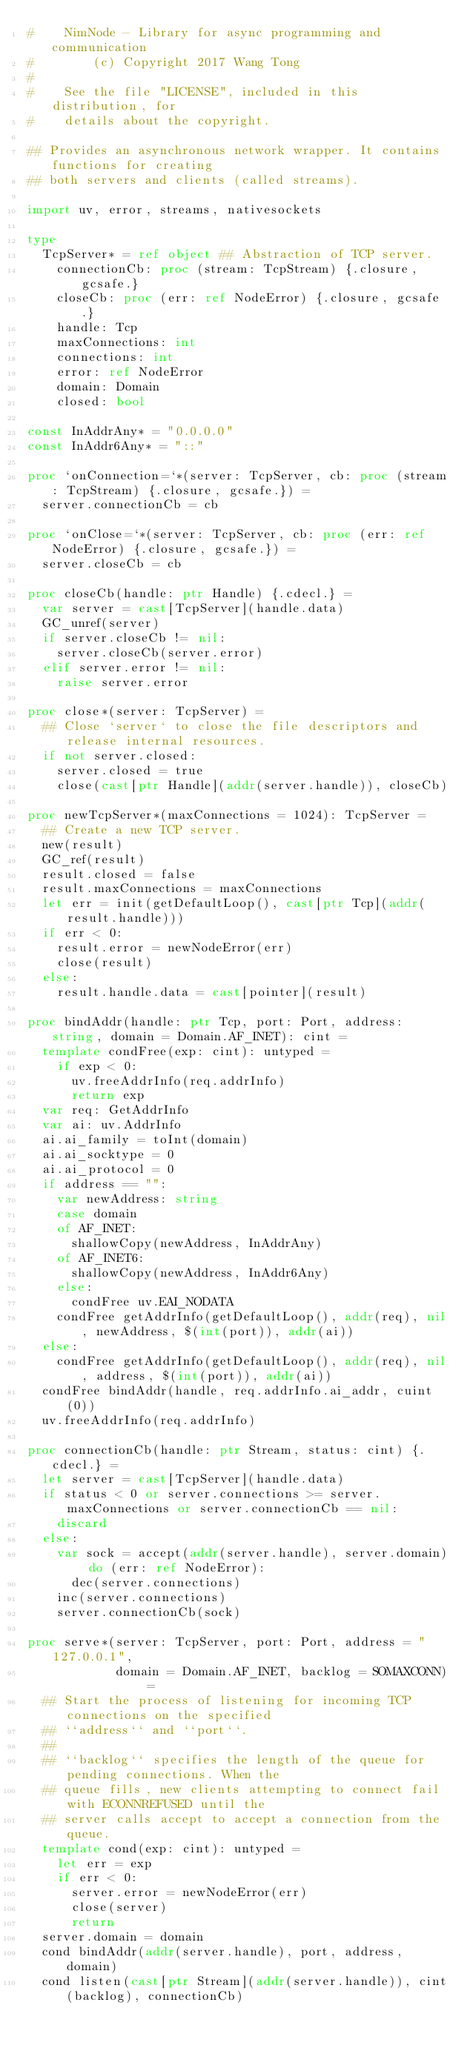Convert code to text. <code><loc_0><loc_0><loc_500><loc_500><_Nim_>#    NimNode - Library for async programming and communication
#        (c) Copyright 2017 Wang Tong
#
#    See the file "LICENSE", included in this distribution, for
#    details about the copyright.

## Provides an asynchronous network wrapper. It contains functions for creating 
## both servers and clients (called streams). 

import uv, error, streams, nativesockets

type
  TcpServer* = ref object ## Abstraction of TCP server.
    connectionCb: proc (stream: TcpStream) {.closure, gcsafe.}
    closeCb: proc (err: ref NodeError) {.closure, gcsafe.}
    handle: Tcp
    maxConnections: int
    connections: int
    error: ref NodeError
    domain: Domain
    closed: bool

const InAddrAny* = "0.0.0.0"
const InAddr6Any* = "::"

proc `onConnection=`*(server: TcpServer, cb: proc (stream: TcpStream) {.closure, gcsafe.}) =
  server.connectionCb = cb

proc `onClose=`*(server: TcpServer, cb: proc (err: ref NodeError) {.closure, gcsafe.}) =
  server.closeCb = cb

proc closeCb(handle: ptr Handle) {.cdecl.} =
  var server = cast[TcpServer](handle.data) 
  GC_unref(server)
  if server.closeCb != nil:
    server.closeCb(server.error)
  elif server.error != nil:
    raise server.error 

proc close*(server: TcpServer) =
  ## Close `server` to close the file descriptors and release internal resources. 
  if not server.closed:
    server.closed = true
    close(cast[ptr Handle](addr(server.handle)), closeCb)

proc newTcpServer*(maxConnections = 1024): TcpServer =
  ## Create a new TCP server.
  new(result)
  GC_ref(result)
  result.closed = false
  result.maxConnections = maxConnections
  let err = init(getDefaultLoop(), cast[ptr Tcp](addr(result.handle)))
  if err < 0:
    result.error = newNodeError(err)
    close(result)
  else:
    result.handle.data = cast[pointer](result)   

proc bindAddr(handle: ptr Tcp, port: Port, address: string, domain = Domain.AF_INET): cint =
  template condFree(exp: cint): untyped =
    if exp < 0:
      uv.freeAddrInfo(req.addrInfo)
      return exp
  var req: GetAddrInfo
  var ai: uv.AddrInfo
  ai.ai_family = toInt(domain)
  ai.ai_socktype = 0
  ai.ai_protocol = 0
  if address == "":
    var newAddress: string 
    case domain
    of AF_INET: 
      shallowCopy(newAddress, InAddrAny)
    of AF_INET6: 
      shallowCopy(newAddress, InAddr6Any)
    else:
      condFree uv.EAI_NODATA
    condFree getAddrInfo(getDefaultLoop(), addr(req), nil, newAddress, $(int(port)), addr(ai))
  else:
    condFree getAddrInfo(getDefaultLoop(), addr(req), nil, address, $(int(port)), addr(ai))
  condFree bindAddr(handle, req.addrInfo.ai_addr, cuint(0))
  uv.freeAddrInfo(req.addrInfo)

proc connectionCb(handle: ptr Stream, status: cint) {.cdecl.} =
  let server = cast[TcpServer](handle.data)
  if status < 0 or server.connections >= server.maxConnections or server.connectionCb == nil:
    discard
  else:
    var sock = accept(addr(server.handle), server.domain) do (err: ref NodeError):
      dec(server.connections)
    inc(server.connections)
    server.connectionCb(sock)

proc serve*(server: TcpServer, port: Port, address = "127.0.0.1",
            domain = Domain.AF_INET, backlog = SOMAXCONN) =
  ## Start the process of listening for incoming TCP connections on the specified 
  ## ``address`` and ``port``. 
  ##
  ## ``backlog`` specifies the length of the queue for pending connections. When the 
  ## queue fills, new clients attempting to connect fail with ECONNREFUSED until the 
  ## server calls accept to accept a connection from the queue.
  template cond(exp: cint): untyped =
    let err = exp
    if err < 0:
      server.error = newNodeError(err)
      close(server)
      return
  server.domain = domain
  cond bindAddr(addr(server.handle), port, address, domain)
  cond listen(cast[ptr Stream](addr(server.handle)), cint(backlog), connectionCb)
  



</code> 